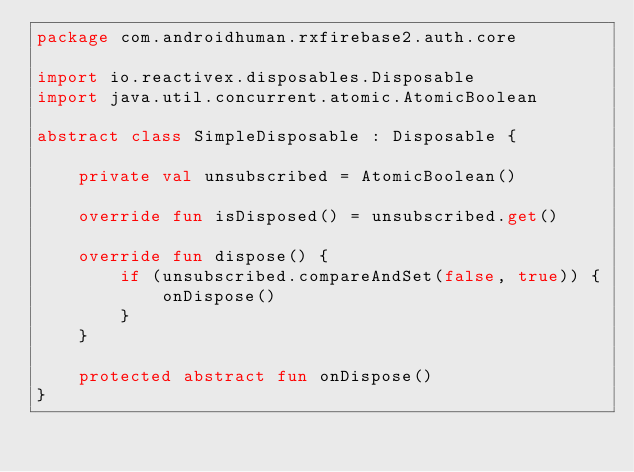Convert code to text. <code><loc_0><loc_0><loc_500><loc_500><_Kotlin_>package com.androidhuman.rxfirebase2.auth.core

import io.reactivex.disposables.Disposable
import java.util.concurrent.atomic.AtomicBoolean

abstract class SimpleDisposable : Disposable {

    private val unsubscribed = AtomicBoolean()

    override fun isDisposed() = unsubscribed.get()

    override fun dispose() {
        if (unsubscribed.compareAndSet(false, true)) {
            onDispose()
        }
    }

    protected abstract fun onDispose()
}
</code> 